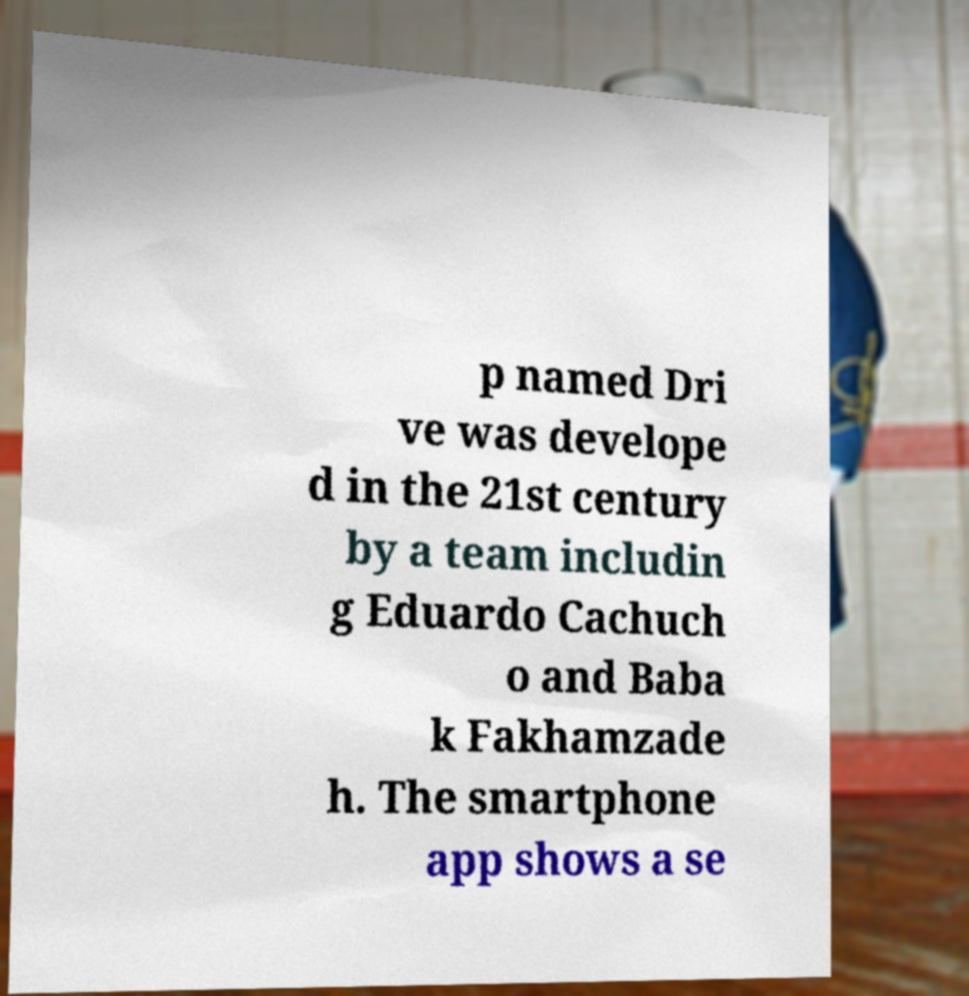For documentation purposes, I need the text within this image transcribed. Could you provide that? p named Dri ve was develope d in the 21st century by a team includin g Eduardo Cachuch o and Baba k Fakhamzade h. The smartphone app shows a se 